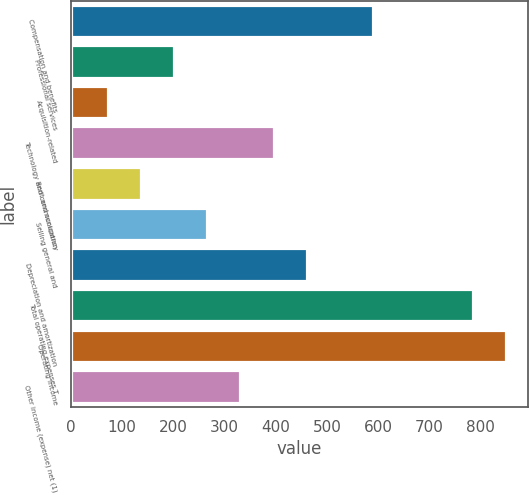<chart> <loc_0><loc_0><loc_500><loc_500><bar_chart><fcel>Compensation and benefits<fcel>Professional services<fcel>Acquisition-related<fcel>Technology and communication<fcel>Rent and occupancy<fcel>Selling general and<fcel>Depreciation and amortization<fcel>Total operating expenses T<fcel>Operating income<fcel>Other income (expense) net (1)<nl><fcel>590.2<fcel>201.4<fcel>71.8<fcel>395.8<fcel>136.6<fcel>266.2<fcel>460.6<fcel>784.6<fcel>849.4<fcel>331<nl></chart> 